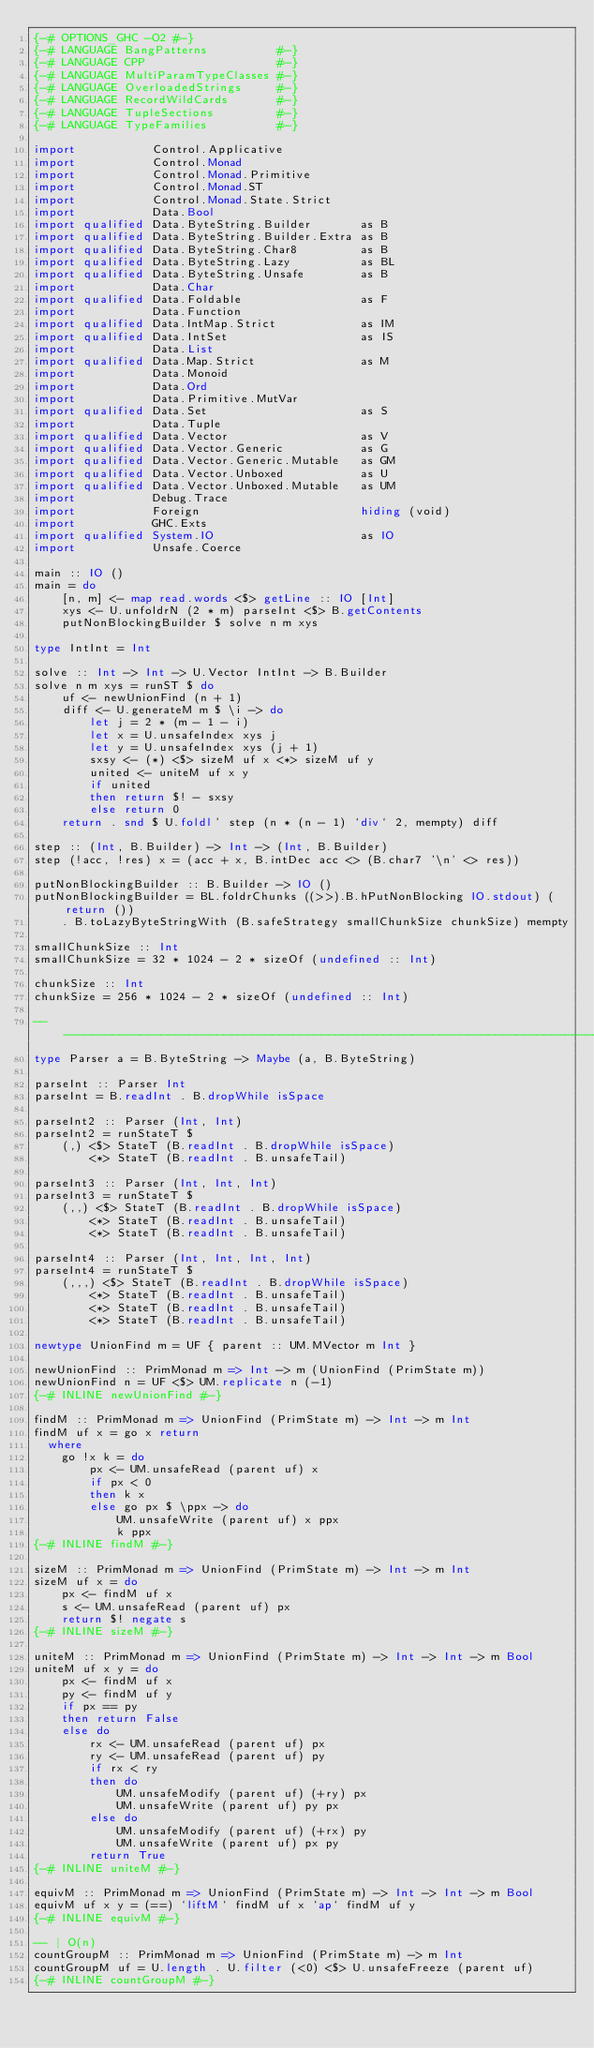Convert code to text. <code><loc_0><loc_0><loc_500><loc_500><_Haskell_>{-# OPTIONS_GHC -O2 #-}
{-# LANGUAGE BangPatterns          #-}
{-# LANGUAGE CPP                   #-}
{-# LANGUAGE MultiParamTypeClasses #-}
{-# LANGUAGE OverloadedStrings     #-}
{-# LANGUAGE RecordWildCards       #-}
{-# LANGUAGE TupleSections         #-}
{-# LANGUAGE TypeFamilies          #-}

import           Control.Applicative
import           Control.Monad
import           Control.Monad.Primitive
import           Control.Monad.ST
import           Control.Monad.State.Strict
import           Data.Bool
import qualified Data.ByteString.Builder       as B
import qualified Data.ByteString.Builder.Extra as B
import qualified Data.ByteString.Char8         as B
import qualified Data.ByteString.Lazy          as BL
import qualified Data.ByteString.Unsafe        as B
import           Data.Char
import qualified Data.Foldable                 as F
import           Data.Function
import qualified Data.IntMap.Strict            as IM
import qualified Data.IntSet                   as IS
import           Data.List
import qualified Data.Map.Strict               as M
import           Data.Monoid
import           Data.Ord
import           Data.Primitive.MutVar
import qualified Data.Set                      as S
import           Data.Tuple
import qualified Data.Vector                   as V
import qualified Data.Vector.Generic           as G
import qualified Data.Vector.Generic.Mutable   as GM
import qualified Data.Vector.Unboxed           as U
import qualified Data.Vector.Unboxed.Mutable   as UM
import           Debug.Trace
import           Foreign                       hiding (void)
import           GHC.Exts
import qualified System.IO                     as IO
import           Unsafe.Coerce

main :: IO ()
main = do
    [n, m] <- map read.words <$> getLine :: IO [Int]
    xys <- U.unfoldrN (2 * m) parseInt <$> B.getContents
    putNonBlockingBuilder $ solve n m xys

type IntInt = Int

solve :: Int -> Int -> U.Vector IntInt -> B.Builder
solve n m xys = runST $ do
    uf <- newUnionFind (n + 1)
    diff <- U.generateM m $ \i -> do
        let j = 2 * (m - 1 - i)
        let x = U.unsafeIndex xys j
        let y = U.unsafeIndex xys (j + 1)
        sxsy <- (*) <$> sizeM uf x <*> sizeM uf y
        united <- uniteM uf x y
        if united
        then return $! - sxsy
        else return 0
    return . snd $ U.foldl' step (n * (n - 1) `div` 2, mempty) diff

step :: (Int, B.Builder) -> Int -> (Int, B.Builder)
step (!acc, !res) x = (acc + x, B.intDec acc <> (B.char7 '\n' <> res))

putNonBlockingBuilder :: B.Builder -> IO ()
putNonBlockingBuilder = BL.foldrChunks ((>>).B.hPutNonBlocking IO.stdout) (return ())
    . B.toLazyByteStringWith (B.safeStrategy smallChunkSize chunkSize) mempty

smallChunkSize :: Int
smallChunkSize = 32 * 1024 - 2 * sizeOf (undefined :: Int)

chunkSize :: Int
chunkSize = 256 * 1024 - 2 * sizeOf (undefined :: Int)

-------------------------------------------------------------------------------
type Parser a = B.ByteString -> Maybe (a, B.ByteString)

parseInt :: Parser Int
parseInt = B.readInt . B.dropWhile isSpace

parseInt2 :: Parser (Int, Int)
parseInt2 = runStateT $
    (,) <$> StateT (B.readInt . B.dropWhile isSpace)
        <*> StateT (B.readInt . B.unsafeTail)

parseInt3 :: Parser (Int, Int, Int)
parseInt3 = runStateT $
    (,,) <$> StateT (B.readInt . B.dropWhile isSpace)
        <*> StateT (B.readInt . B.unsafeTail)
        <*> StateT (B.readInt . B.unsafeTail)

parseInt4 :: Parser (Int, Int, Int, Int)
parseInt4 = runStateT $
    (,,,) <$> StateT (B.readInt . B.dropWhile isSpace)
        <*> StateT (B.readInt . B.unsafeTail)
        <*> StateT (B.readInt . B.unsafeTail)
        <*> StateT (B.readInt . B.unsafeTail)

newtype UnionFind m = UF { parent :: UM.MVector m Int }

newUnionFind :: PrimMonad m => Int -> m (UnionFind (PrimState m))
newUnionFind n = UF <$> UM.replicate n (-1)
{-# INLINE newUnionFind #-}

findM :: PrimMonad m => UnionFind (PrimState m) -> Int -> m Int
findM uf x = go x return
  where
    go !x k = do
        px <- UM.unsafeRead (parent uf) x
        if px < 0
        then k x
        else go px $ \ppx -> do
            UM.unsafeWrite (parent uf) x ppx
            k ppx
{-# INLINE findM #-}

sizeM :: PrimMonad m => UnionFind (PrimState m) -> Int -> m Int
sizeM uf x = do
    px <- findM uf x
    s <- UM.unsafeRead (parent uf) px
    return $! negate s
{-# INLINE sizeM #-}

uniteM :: PrimMonad m => UnionFind (PrimState m) -> Int -> Int -> m Bool
uniteM uf x y = do
    px <- findM uf x
    py <- findM uf y
    if px == py
    then return False
    else do
        rx <- UM.unsafeRead (parent uf) px
        ry <- UM.unsafeRead (parent uf) py
        if rx < ry
        then do
            UM.unsafeModify (parent uf) (+ry) px
            UM.unsafeWrite (parent uf) py px
        else do
            UM.unsafeModify (parent uf) (+rx) py
            UM.unsafeWrite (parent uf) px py
        return True
{-# INLINE uniteM #-}

equivM :: PrimMonad m => UnionFind (PrimState m) -> Int -> Int -> m Bool
equivM uf x y = (==) `liftM` findM uf x `ap` findM uf y
{-# INLINE equivM #-}

-- | O(n)
countGroupM :: PrimMonad m => UnionFind (PrimState m) -> m Int
countGroupM uf = U.length . U.filter (<0) <$> U.unsafeFreeze (parent uf)
{-# INLINE countGroupM #-}
</code> 